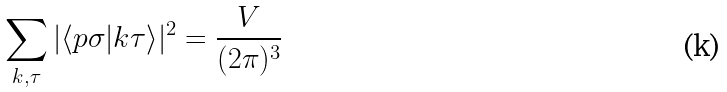<formula> <loc_0><loc_0><loc_500><loc_500>\sum _ { { k } , \tau } | \langle { p } \sigma | { k } \tau \rangle | ^ { 2 } = \frac { V } { ( 2 \pi ) ^ { 3 } }</formula> 